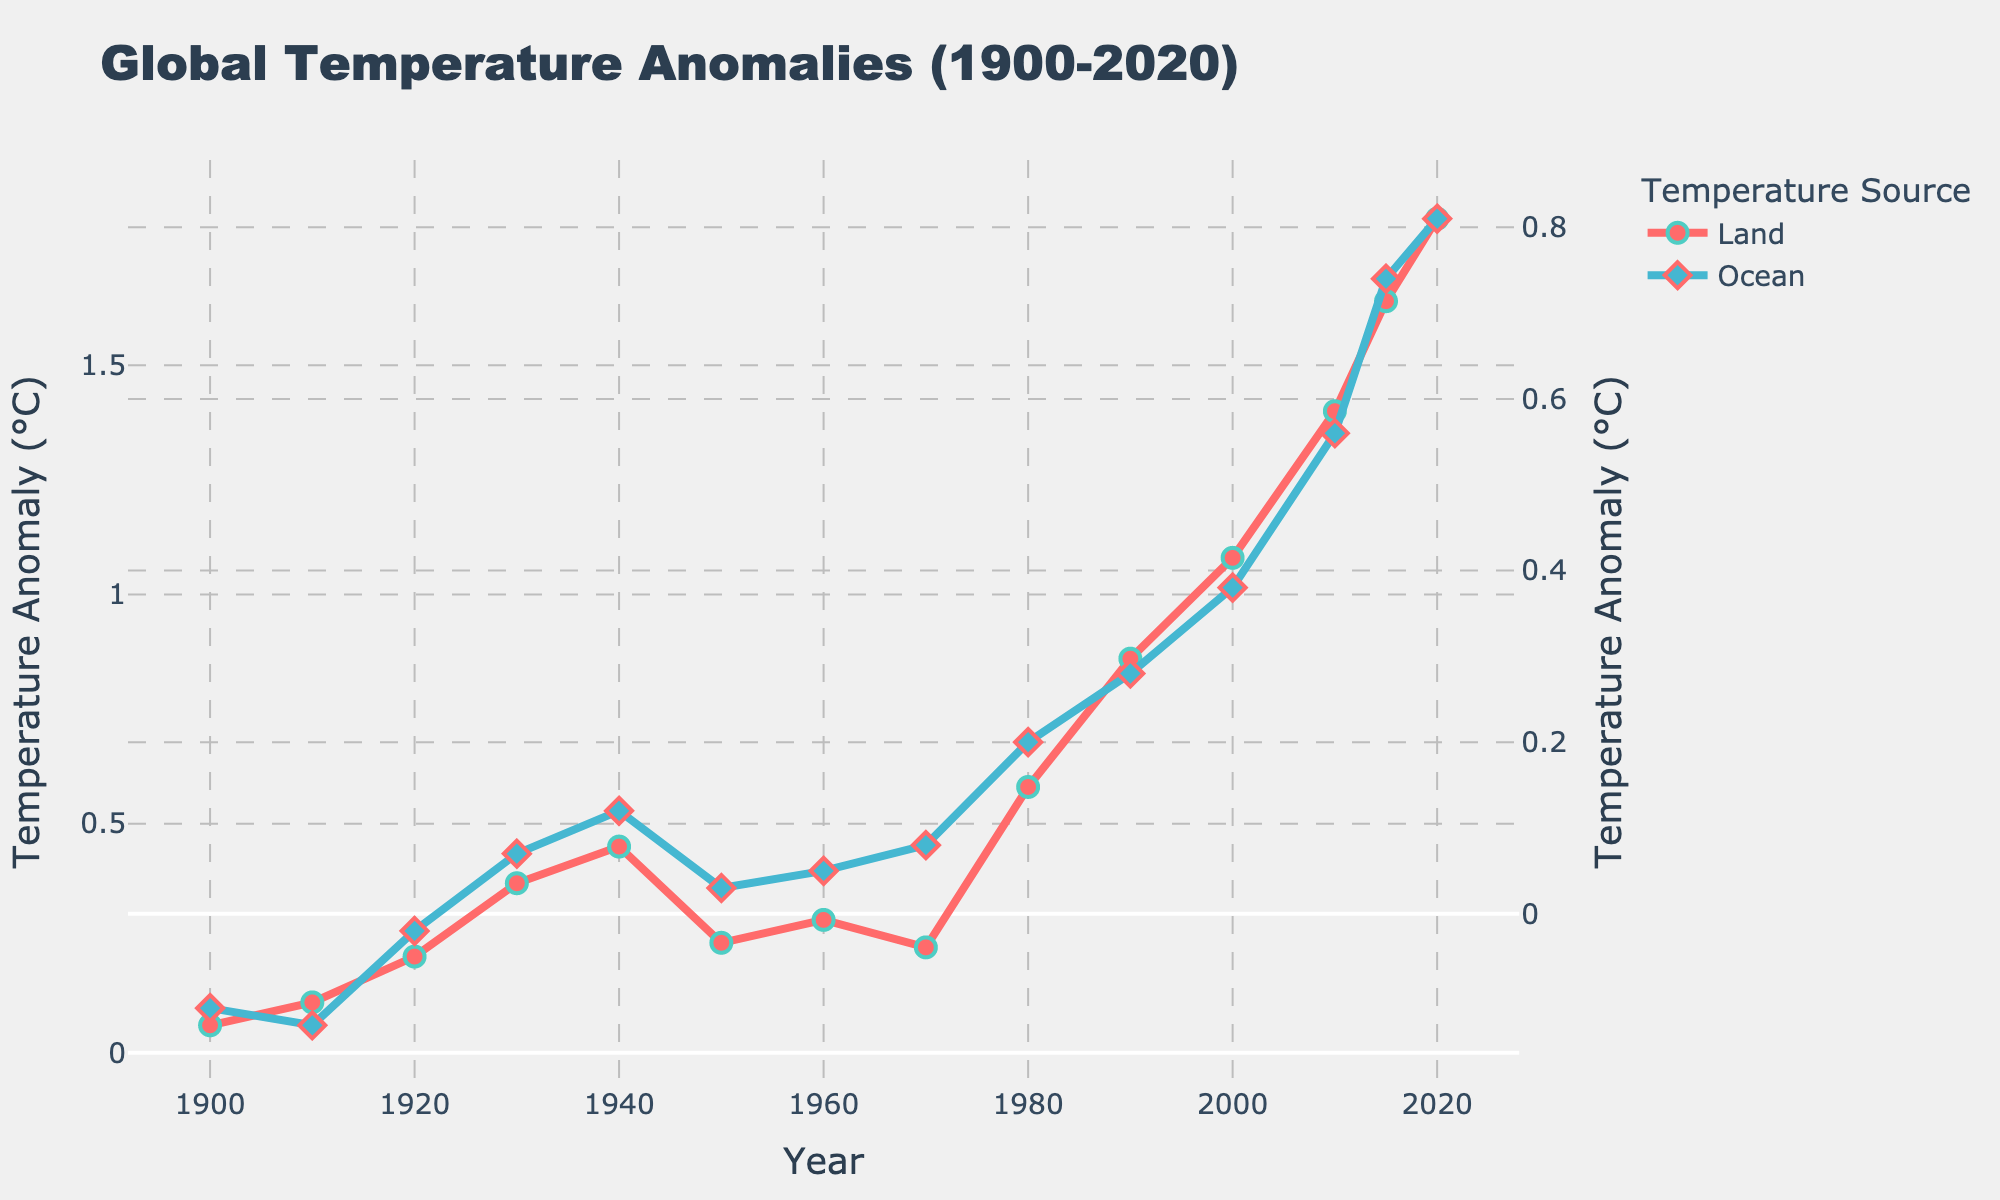When did the land temperature anomaly first exceed 1°C? First, locate the point where the land temperature anomaly surpasses 1°C on the line chart. The data shows that in the year 2000, the land temperature anomaly was 1.08°C, which is the first time it exceeds 1°C. Therefore, it's in the year 2000.
Answer: 2000 Which type of anomaly had the highest value in 2020? Locate the data points for the year 2020. The land temperature anomaly in 2020 is 1.82°C, and the ocean temperature anomaly is 0.81°C. Compare these values; the higher one is 1.82°C. Therefore, the land temperature anomaly is the highest in 2020.
Answer: Land temperature anomaly What is the trend of the ocean temperature anomaly between 1950 and 1980? Identify the data points between 1950 and 1980 for the ocean temperature anomaly. The anomalies are: 1950 (0.03°C), 1960 (0.05°C), 1970 (0.08°C), and 1980 (0.20°C). Observing these values, the ocean temperature anomaly is consistently increasing during this period.
Answer: Increasing By how much did the land temperature anomaly increase from 1900 to 2020? Locate the data points for the years 1900 and 2020. The anomaly values are 0.06°C in 1900 and 1.82°C in 2020. Calculate the difference: 1.82°C - 0.06°C = 1.76°C. Therefore, the increase is 1.76°C.
Answer: 1.76°C Compare the temperature anomalies for land and ocean in the 1940s. Which one was higher and by how much? In the 1940s, locate the data points: land temperature anomaly is 0.45°C, and ocean temperature anomaly is 0.12°C. Calculate the difference: 0.45°C - 0.12°C = 0.33°C. The land temperature anomaly was higher by 0.33°C.
Answer: Land by 0.33°C What is the overall trend of land temperature anomalies over the entire period shown (1900-2020)? Examine the line representing land temperature anomalies from 1900 to 2020. Observing this line, it consistently rises, indicating an overall increasing trend in the land temperature anomalies over the entire period.
Answer: Increasing Is there any period where the ocean temperature anomaly remained relatively constant? If yes, specify the period. Examine the ocean temperature anomaly line for any segment where the values do not change significantly. From 1900 to 1940, the values oscillate but remain close to around -0.11°C to 0.12°C, showing a relatively constant period.
Answer: 1900 to 1940 